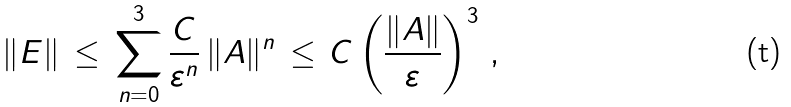<formula> <loc_0><loc_0><loc_500><loc_500>\| E \| \, \leq \, \sum _ { n = 0 } ^ { 3 } \frac { C } { \varepsilon ^ { n } } \, \| A \| ^ { n } \, \leq \, C \left ( \frac { \| A \| } { \varepsilon } \right ) ^ { 3 } \, ,</formula> 